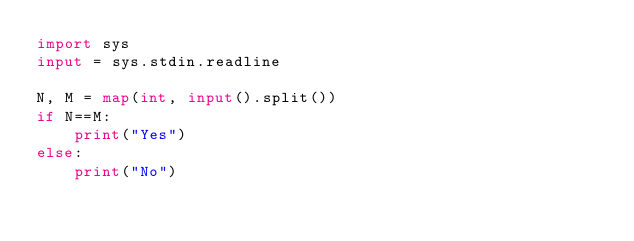<code> <loc_0><loc_0><loc_500><loc_500><_Python_>import sys
input = sys.stdin.readline

N, M = map(int, input().split())
if N==M:
    print("Yes")
else:
    print("No")
    </code> 